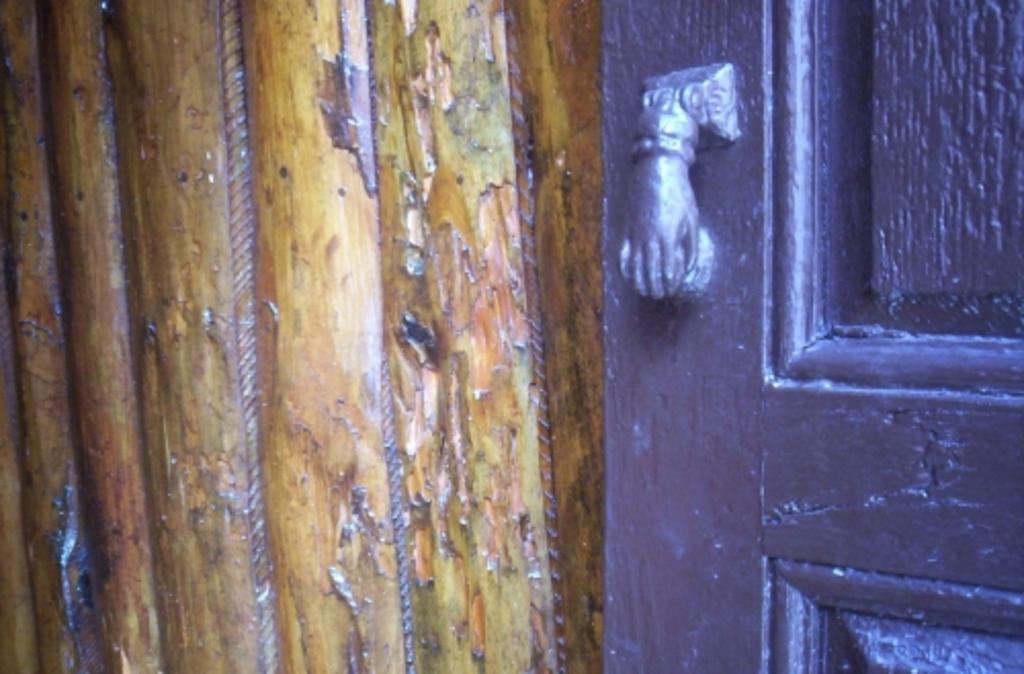Please provide a concise description of this image. On the right side of the image there is a door, on the left side there is a wooden plank. 